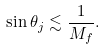Convert formula to latex. <formula><loc_0><loc_0><loc_500><loc_500>\sin \theta _ { j } \lesssim \frac { 1 } { M _ { f } } .</formula> 